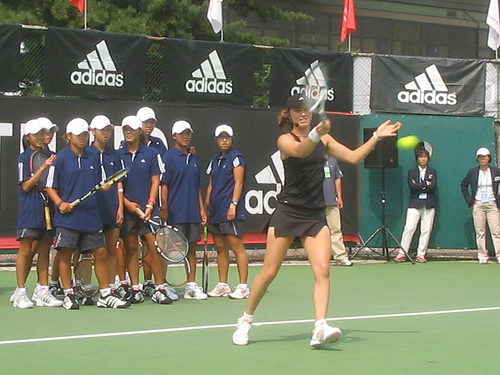<image>
Can you confirm if the tennis ball is above the ground? Yes. The tennis ball is positioned above the ground in the vertical space, higher up in the scene. 